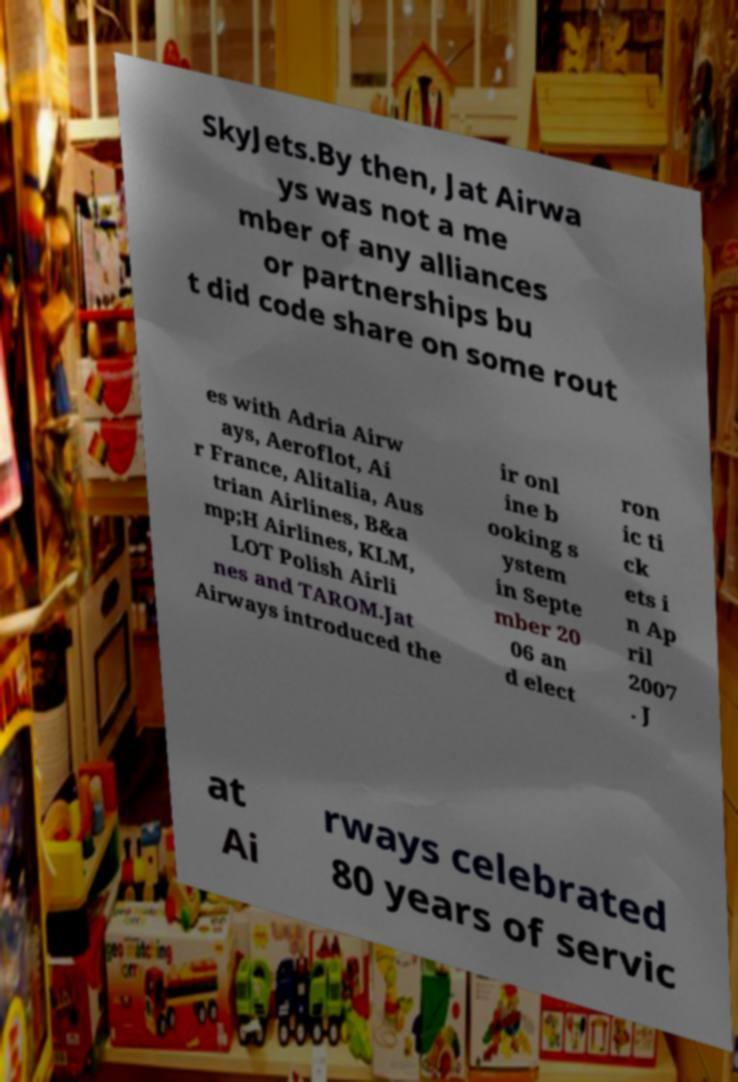Could you extract and type out the text from this image? SkyJets.By then, Jat Airwa ys was not a me mber of any alliances or partnerships bu t did code share on some rout es with Adria Airw ays, Aeroflot, Ai r France, Alitalia, Aus trian Airlines, B&a mp;H Airlines, KLM, LOT Polish Airli nes and TAROM.Jat Airways introduced the ir onl ine b ooking s ystem in Septe mber 20 06 an d elect ron ic ti ck ets i n Ap ril 2007 . J at Ai rways celebrated 80 years of servic 